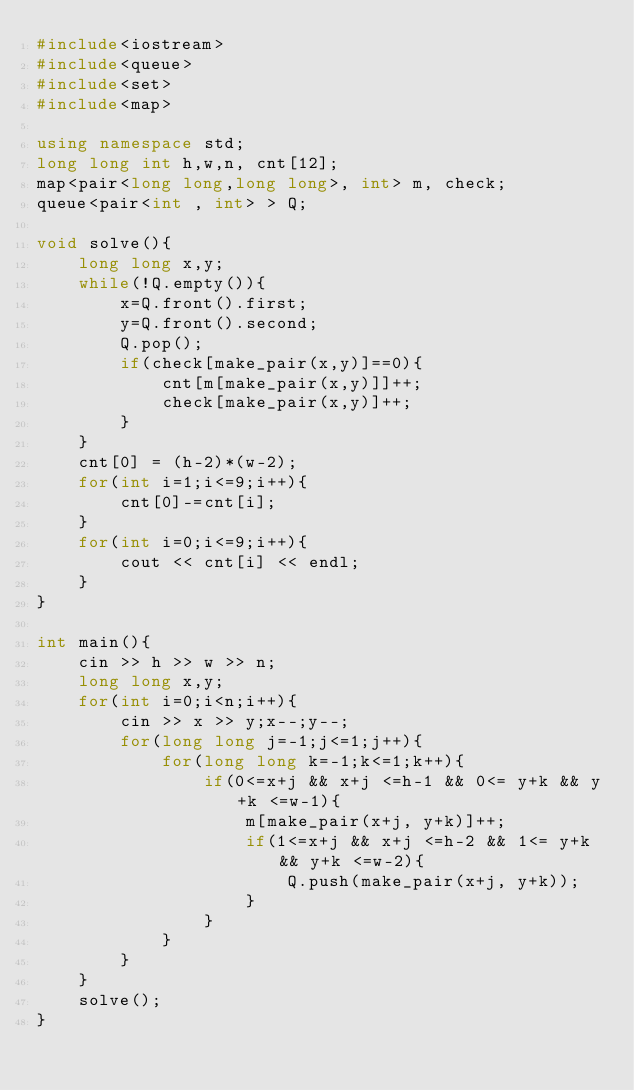<code> <loc_0><loc_0><loc_500><loc_500><_C++_>#include<iostream>
#include<queue>
#include<set>
#include<map>

using namespace std;
long long int h,w,n, cnt[12];
map<pair<long long,long long>, int> m, check;
queue<pair<int , int> > Q;

void solve(){
    long long x,y;
    while(!Q.empty()){
        x=Q.front().first;
        y=Q.front().second;
        Q.pop();
        if(check[make_pair(x,y)]==0){
            cnt[m[make_pair(x,y)]]++;
            check[make_pair(x,y)]++;
        } 
    }
    cnt[0] = (h-2)*(w-2);
    for(int i=1;i<=9;i++){
        cnt[0]-=cnt[i];
    }
    for(int i=0;i<=9;i++){
        cout << cnt[i] << endl;
    }
}

int main(){
    cin >> h >> w >> n;
    long long x,y;
    for(int i=0;i<n;i++){
        cin >> x >> y;x--;y--;
        for(long long j=-1;j<=1;j++){
            for(long long k=-1;k<=1;k++){
                if(0<=x+j && x+j <=h-1 && 0<= y+k && y+k <=w-1){
                    m[make_pair(x+j, y+k)]++;
                    if(1<=x+j && x+j <=h-2 && 1<= y+k && y+k <=w-2){
                        Q.push(make_pair(x+j, y+k));
                    }
                }
            }
        }
    }
    solve();
}
</code> 